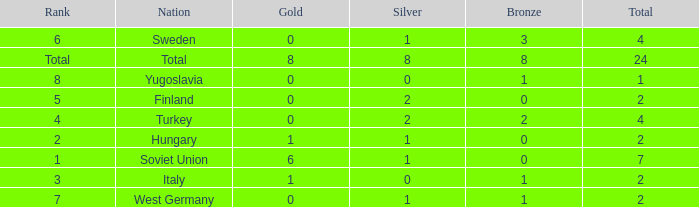What is the sum of Total, when Rank is 8, and when Bronze is less than 1? None. 